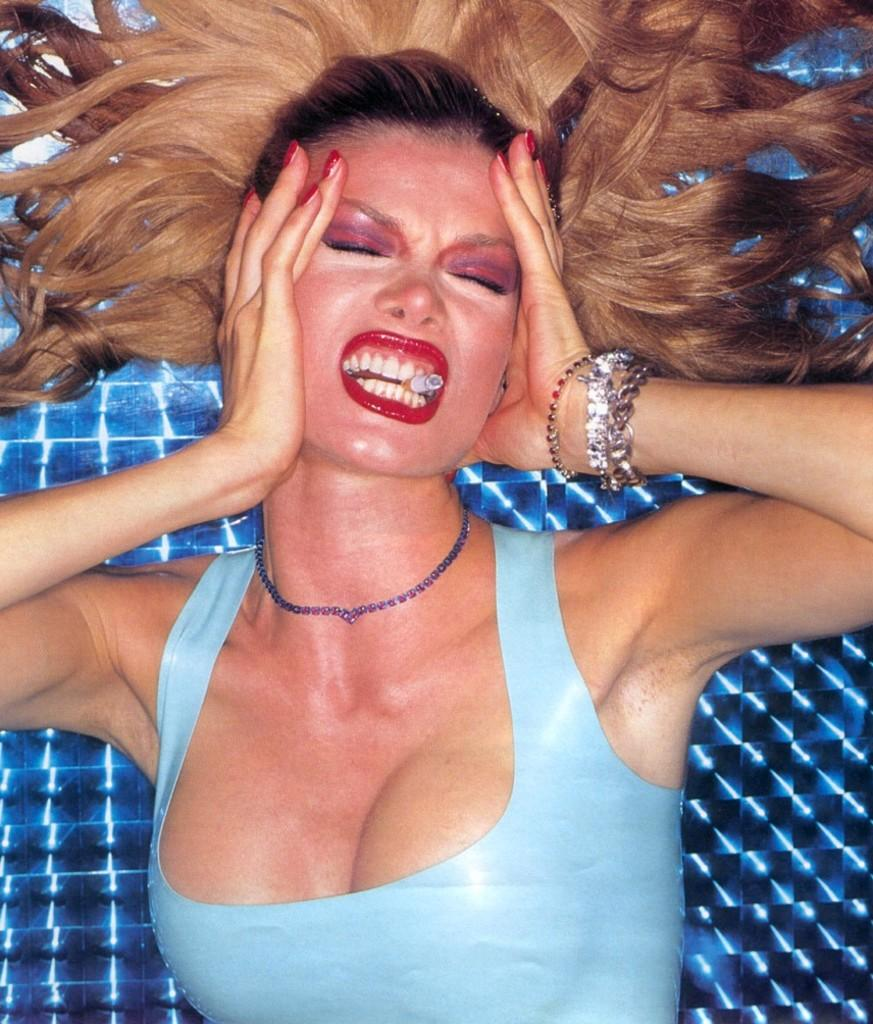Who is the main subject in the image? There is a lady in the center of the image. What is the lady doing in the image? The lady has a cigarette in her mouth. How many ladybugs can be seen on the lady's shoulder in the image? There are no ladybugs present in the image. 